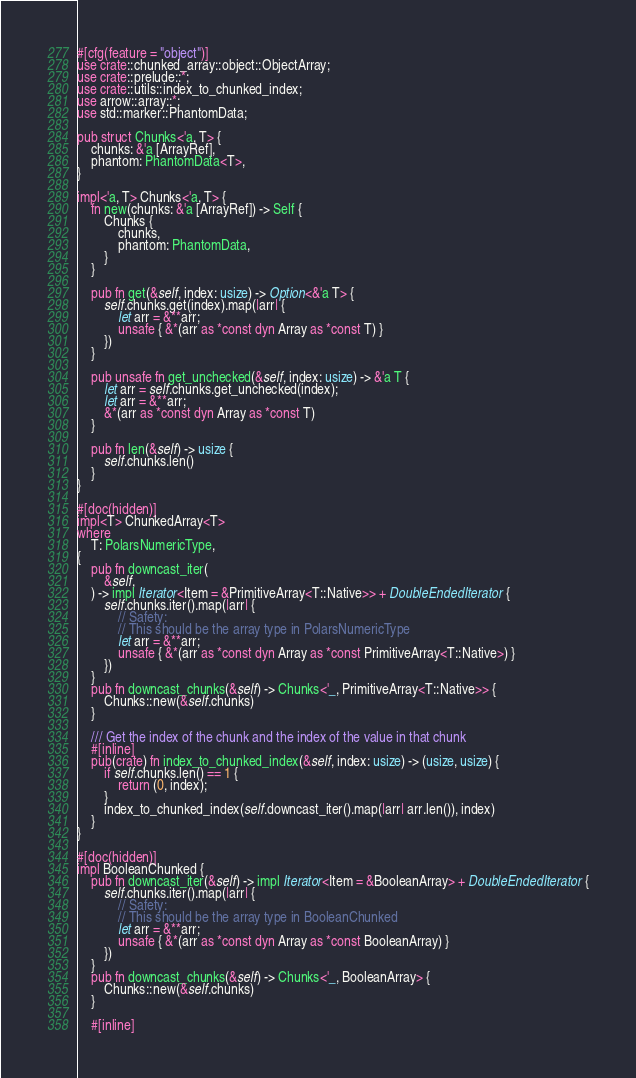Convert code to text. <code><loc_0><loc_0><loc_500><loc_500><_Rust_>#[cfg(feature = "object")]
use crate::chunked_array::object::ObjectArray;
use crate::prelude::*;
use crate::utils::index_to_chunked_index;
use arrow::array::*;
use std::marker::PhantomData;

pub struct Chunks<'a, T> {
    chunks: &'a [ArrayRef],
    phantom: PhantomData<T>,
}

impl<'a, T> Chunks<'a, T> {
    fn new(chunks: &'a [ArrayRef]) -> Self {
        Chunks {
            chunks,
            phantom: PhantomData,
        }
    }

    pub fn get(&self, index: usize) -> Option<&'a T> {
        self.chunks.get(index).map(|arr| {
            let arr = &**arr;
            unsafe { &*(arr as *const dyn Array as *const T) }
        })
    }

    pub unsafe fn get_unchecked(&self, index: usize) -> &'a T {
        let arr = self.chunks.get_unchecked(index);
        let arr = &**arr;
        &*(arr as *const dyn Array as *const T)
    }

    pub fn len(&self) -> usize {
        self.chunks.len()
    }
}

#[doc(hidden)]
impl<T> ChunkedArray<T>
where
    T: PolarsNumericType,
{
    pub fn downcast_iter(
        &self,
    ) -> impl Iterator<Item = &PrimitiveArray<T::Native>> + DoubleEndedIterator {
        self.chunks.iter().map(|arr| {
            // Safety:
            // This should be the array type in PolarsNumericType
            let arr = &**arr;
            unsafe { &*(arr as *const dyn Array as *const PrimitiveArray<T::Native>) }
        })
    }
    pub fn downcast_chunks(&self) -> Chunks<'_, PrimitiveArray<T::Native>> {
        Chunks::new(&self.chunks)
    }

    /// Get the index of the chunk and the index of the value in that chunk
    #[inline]
    pub(crate) fn index_to_chunked_index(&self, index: usize) -> (usize, usize) {
        if self.chunks.len() == 1 {
            return (0, index);
        }
        index_to_chunked_index(self.downcast_iter().map(|arr| arr.len()), index)
    }
}

#[doc(hidden)]
impl BooleanChunked {
    pub fn downcast_iter(&self) -> impl Iterator<Item = &BooleanArray> + DoubleEndedIterator {
        self.chunks.iter().map(|arr| {
            // Safety:
            // This should be the array type in BooleanChunked
            let arr = &**arr;
            unsafe { &*(arr as *const dyn Array as *const BooleanArray) }
        })
    }
    pub fn downcast_chunks(&self) -> Chunks<'_, BooleanArray> {
        Chunks::new(&self.chunks)
    }

    #[inline]</code> 